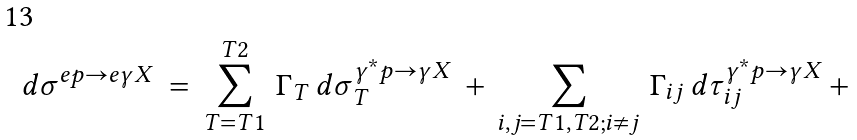<formula> <loc_0><loc_0><loc_500><loc_500>d \sigma ^ { e p \rightarrow e \gamma X } \, = \, \sum _ { T = T 1 } ^ { T 2 } \, \Gamma _ { T } \, d \sigma ^ { \gamma ^ { \ast } p \rightarrow \gamma X } _ { T } \, + \, \sum _ { i , j = T 1 , T 2 ; i \neq j } \, \Gamma _ { i j } \, d \tau ^ { \gamma ^ { \ast } p \rightarrow \gamma X } _ { i j } \, + \,</formula> 